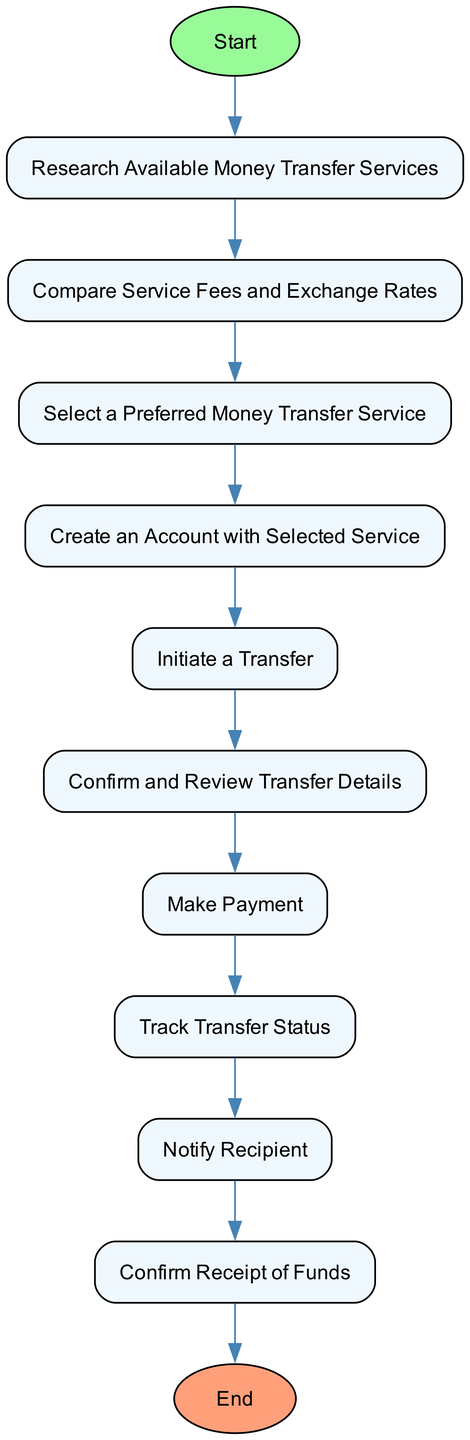What is the first step in the flow chart? The first step, indicated by the arrow leading from the "Start" node, is "Research Available Money Transfer Services." This step is the entry point of the flow chart, leading directly to the next action.
Answer: Research Available Money Transfer Services How many steps are there in total? By counting the number of nodes labeled with steps, we find there are ten distinct steps between the "Start" and "End" nodes. Each unique action represents a step in the process.
Answer: 10 What is the last action before completion of the transfer process? The last action before reaching the "End" node is "Confirm Receipt of Funds." This indicates the final verification step after the transfer has been initiated and processed.
Answer: Confirm Receipt of Funds Which step involves comparing costs? The step that involves comparing costs is "Compare Service Fees and Exchange Rates." This is crucial for selecting the most economical transfer option.
Answer: Compare Service Fees and Exchange Rates What is the relationship between "Initiate a Transfer" and "Track Transfer Status"? "Initiate a Transfer" is followed by "Track Transfer Status." After entering recipient details and amount, tracking becomes essential to monitor the transfer's progress.
Answer: Sequential relationship How do you inform the recipient about the transfer? You inform the recipient using the step "Notify Recipient," which entails communicating details about the initiated transfer for their awareness and preparation.
Answer: Notify Recipient What action follows "Confirm and Review Transfer Details"? The action that follows is "Make Payment." After confirming details, the next logical step is to process the payment for the transfer.
Answer: Make Payment Which transfer service should be selected? You should select a service in the "Select a Preferred Money Transfer Service" step based on a comparison of fees, exchange rates, and reliability.
Answer: Preferred Money Transfer Service What payment methods can be used in the money transfer process? The payment methods mentioned in the diagram under "Make Payment" include bank transfer, debit card, or credit card. Each option provides a way to fund the transaction.
Answer: Bank transfer, debit card, credit card 